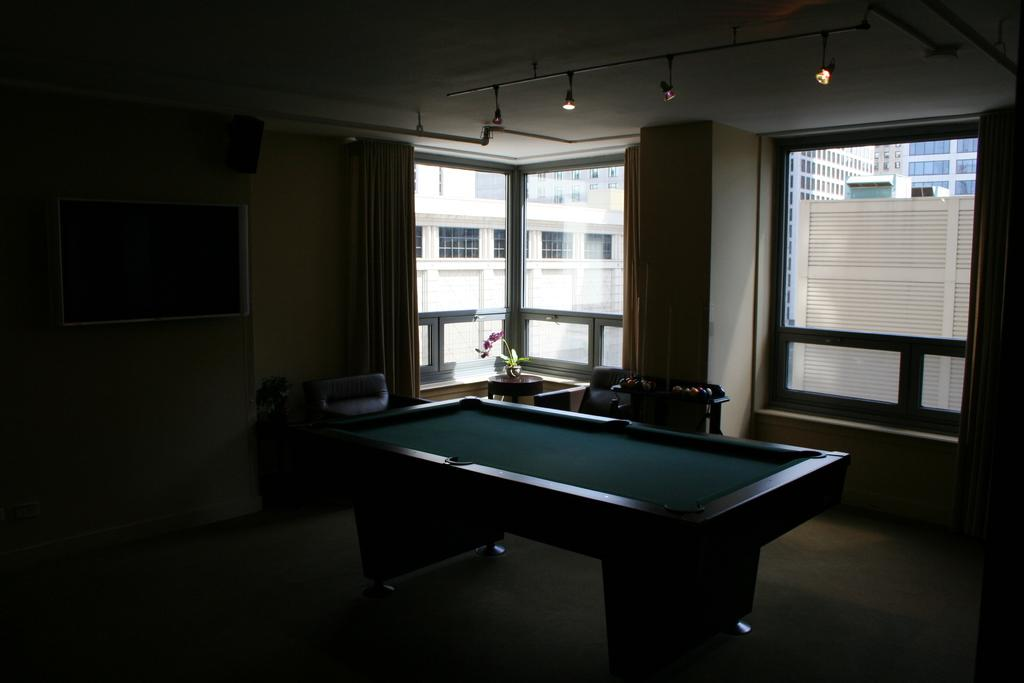What type of table is present in the room? There is a billiards table in the room. What type of window treatment is present in the room? There are curtains in the room. What objects are on a table in the room? There are balls on a table in the room. What type of decorative item is present in the room? There is a flower vase in the room. What type of wall decoration is present in the room? There is a frame on the wall in the room. What architectural feature is present in the room? There is a window in the room. What can be seen through the window? Buildings are visible through the window. How does the brake work on the flower vase in the room? There is no brake on the flower vase in the room; it is a decorative item and does not have any mechanical components. What time of day is it in the room, given that it is night? The time of day cannot be determined from the image, as there is no information about the lighting or time of day provided. 